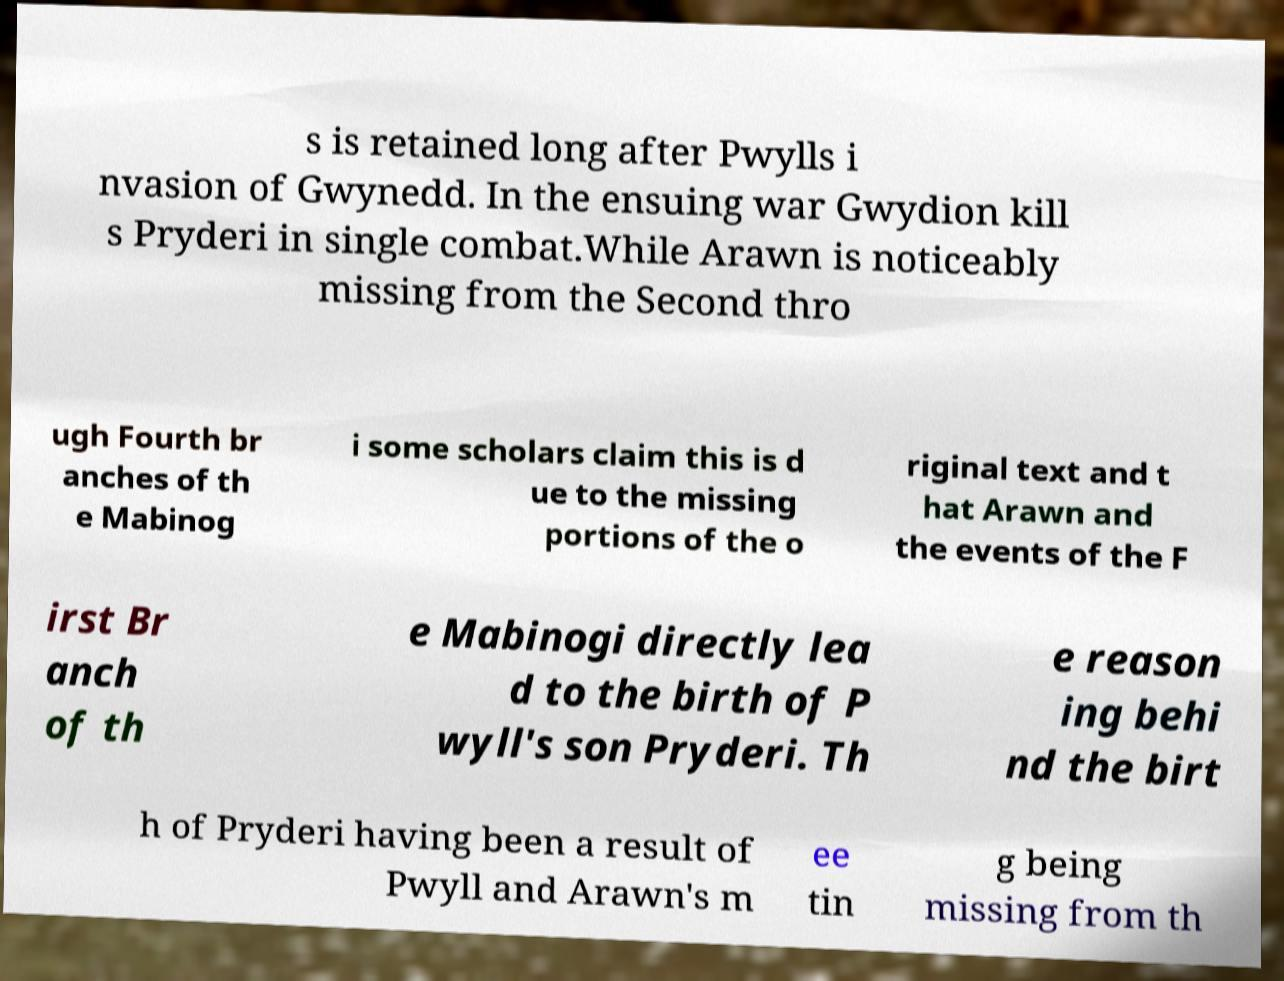Please read and relay the text visible in this image. What does it say? s is retained long after Pwylls i nvasion of Gwynedd. In the ensuing war Gwydion kill s Pryderi in single combat.While Arawn is noticeably missing from the Second thro ugh Fourth br anches of th e Mabinog i some scholars claim this is d ue to the missing portions of the o riginal text and t hat Arawn and the events of the F irst Br anch of th e Mabinogi directly lea d to the birth of P wyll's son Pryderi. Th e reason ing behi nd the birt h of Pryderi having been a result of Pwyll and Arawn's m ee tin g being missing from th 